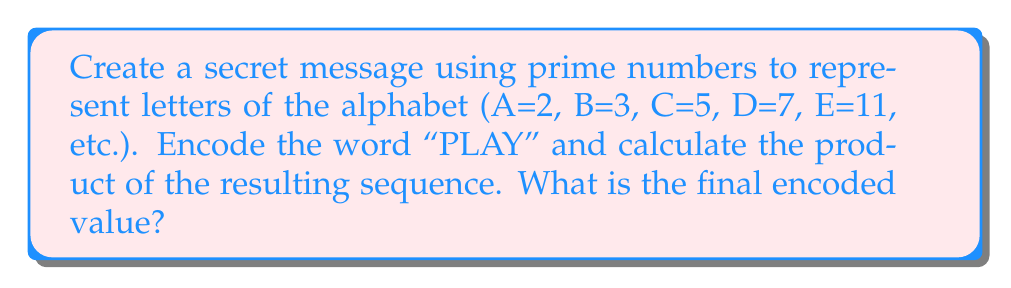Can you answer this question? Let's approach this step-by-step:

1) First, we need to assign prime numbers to each letter of the alphabet:
   A=2, B=3, C=5, D=7, E=11, F=13, G=17, H=19, I=23, J=29, K=31, L=37, M=41,
   N=43, O=47, P=53, Q=59, R=61, S=67, T=71, U=73, V=79, W=83, X=89, Y=97, Z=101

2) Now, let's encode the word "PLAY":
   P = 53
   L = 37
   A = 2
   Y = 97

3) Our sequence of prime numbers is thus: 53, 37, 2, 97

4) To get the final encoded value, we need to calculate the product of these numbers:

   $$ 53 \times 37 \times 2 \times 97 = 380,282 $$

5) Therefore, the final encoded value is 380,282.

This encoding method allows for self-directed exploration of prime numbers, multiplication of large numbers, and the concept of encoding messages, all of which align with the unschooling approach.
Answer: 380,282 